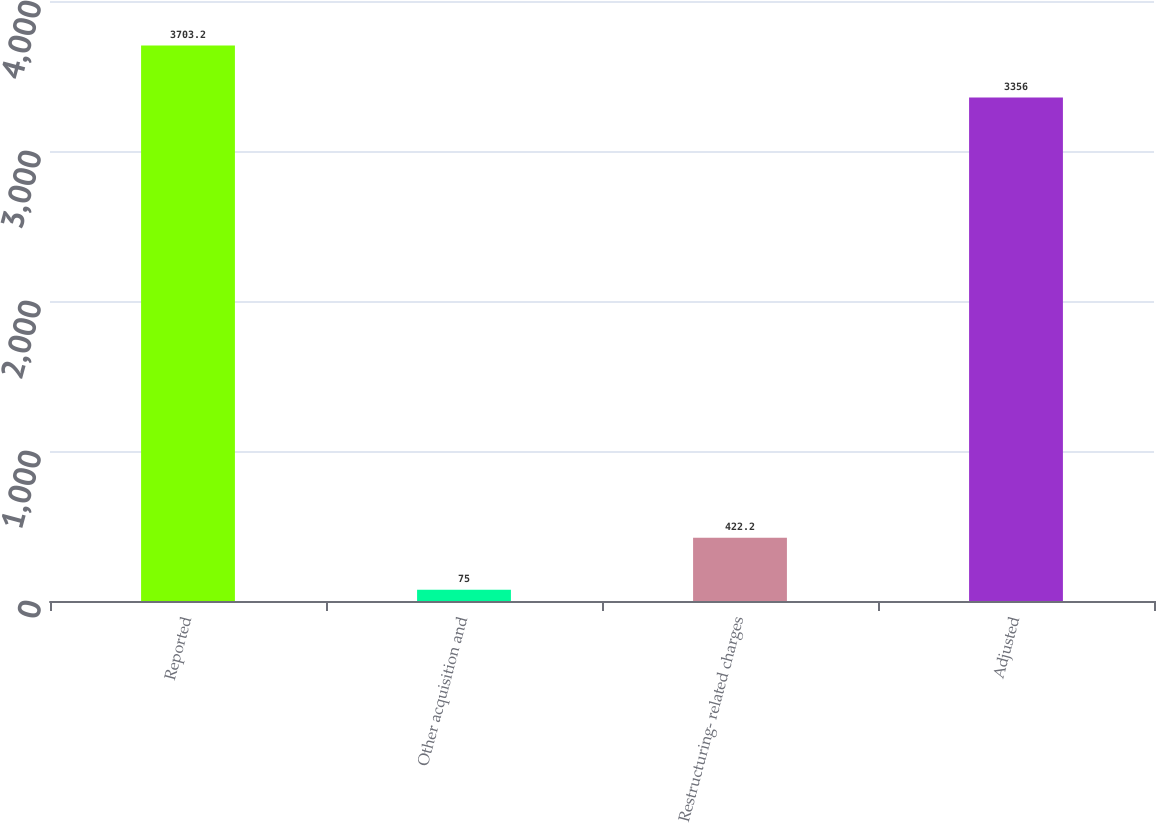Convert chart to OTSL. <chart><loc_0><loc_0><loc_500><loc_500><bar_chart><fcel>Reported<fcel>Other acquisition and<fcel>Restructuring- related charges<fcel>Adjusted<nl><fcel>3703.2<fcel>75<fcel>422.2<fcel>3356<nl></chart> 